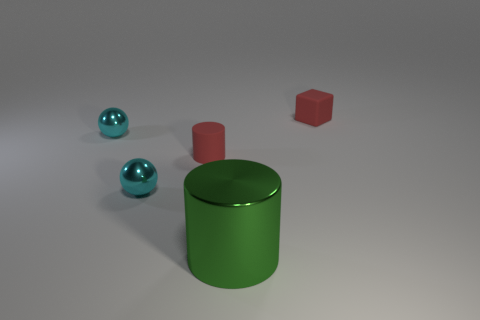Is the tiny red object behind the matte cylinder made of the same material as the small ball in front of the tiny cylinder?
Give a very brief answer. No. What number of large metal objects are in front of the small shiny thing that is in front of the red rubber thing left of the green metal thing?
Your answer should be very brief. 1. Do the cylinder that is behind the big object and the large metallic object that is in front of the tiny matte block have the same color?
Your answer should be very brief. No. Is there any other thing that is the same color as the tiny cylinder?
Make the answer very short. Yes. What color is the metal ball that is behind the small red object that is on the left side of the matte block?
Give a very brief answer. Cyan. Are there any red objects?
Offer a very short reply. Yes. What color is the object that is both behind the big object and in front of the red rubber cylinder?
Make the answer very short. Cyan. Does the matte thing that is right of the green cylinder have the same size as the rubber cylinder that is in front of the tiny red block?
Your response must be concise. Yes. How many other things are there of the same size as the red cylinder?
Make the answer very short. 3. There is a matte object that is in front of the red cube; what number of red cubes are behind it?
Offer a terse response. 1. 